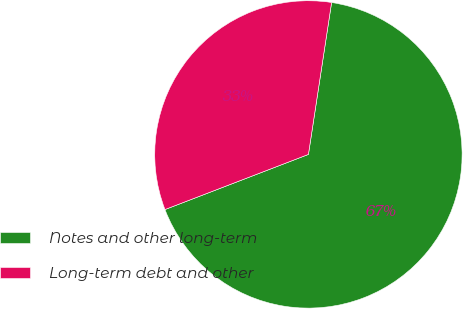Convert chart to OTSL. <chart><loc_0><loc_0><loc_500><loc_500><pie_chart><fcel>Notes and other long-term<fcel>Long-term debt and other<nl><fcel>66.75%<fcel>33.25%<nl></chart> 